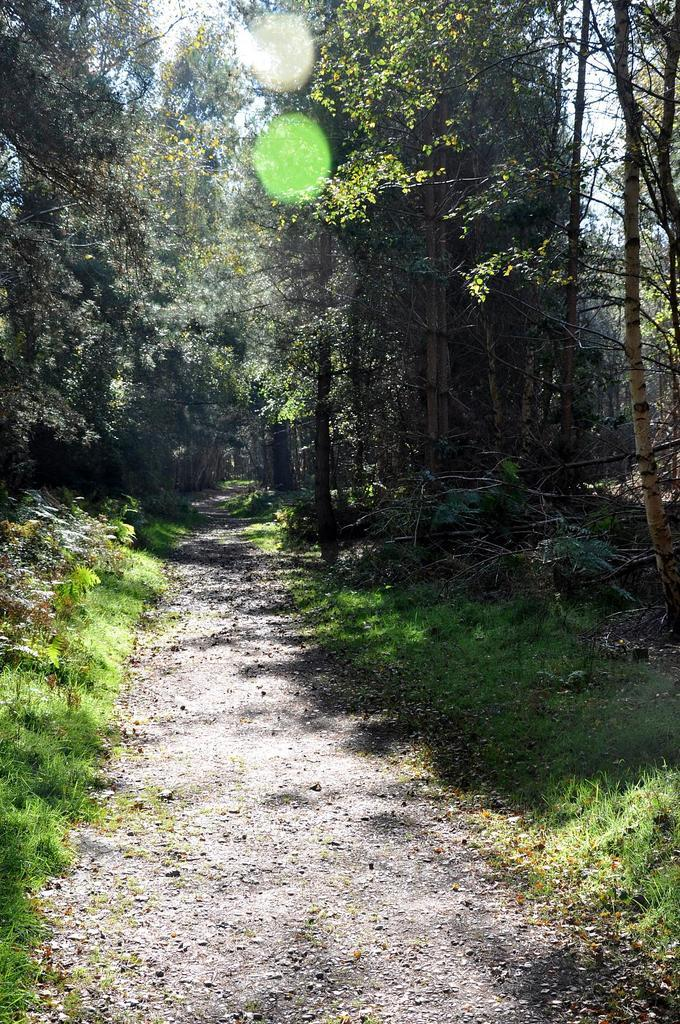What is located at the bottom of the image? There is a small road at the bottom of the image. What can be seen in the background of the image? There are trees in the background of the image. How many mice are hiding in the trees in the image? There are no mice present in the image; it only features a small road and trees. 